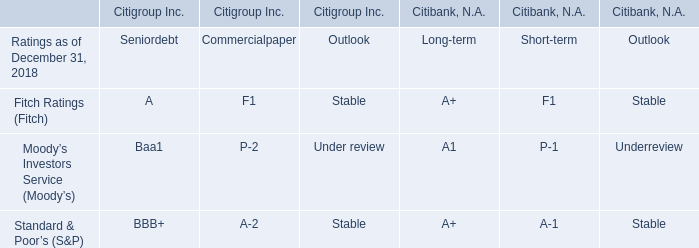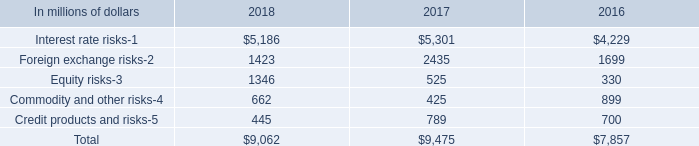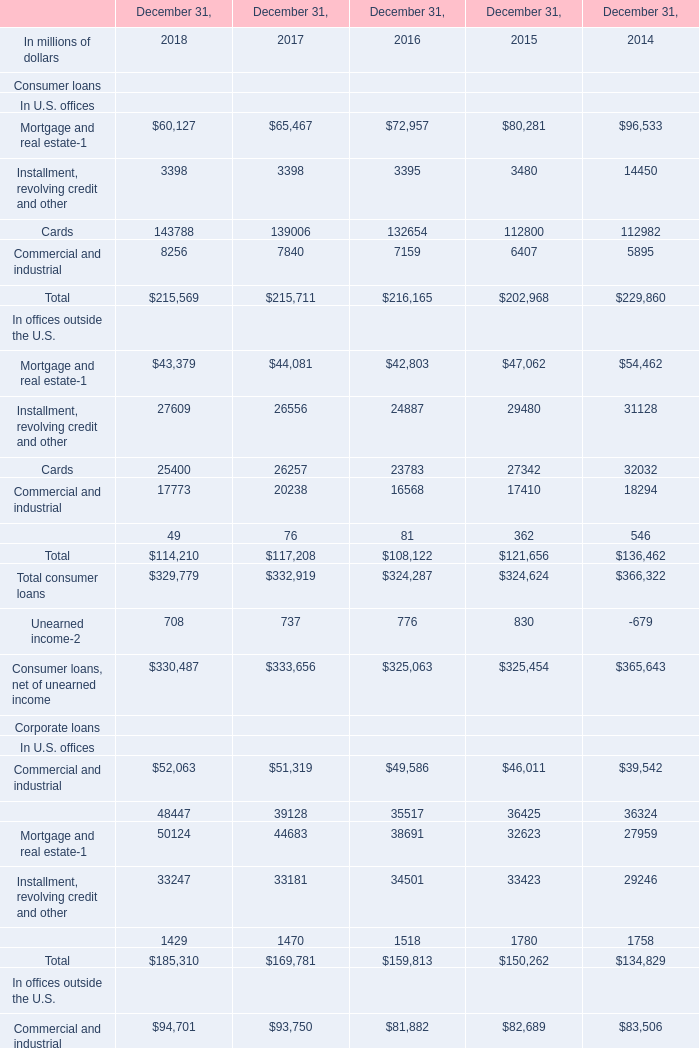What's the average of Mortgage and real estate in 2018 and 2017? (in millions) 
Computations: ((60127 + 65467) / 2)
Answer: 62797.0. 